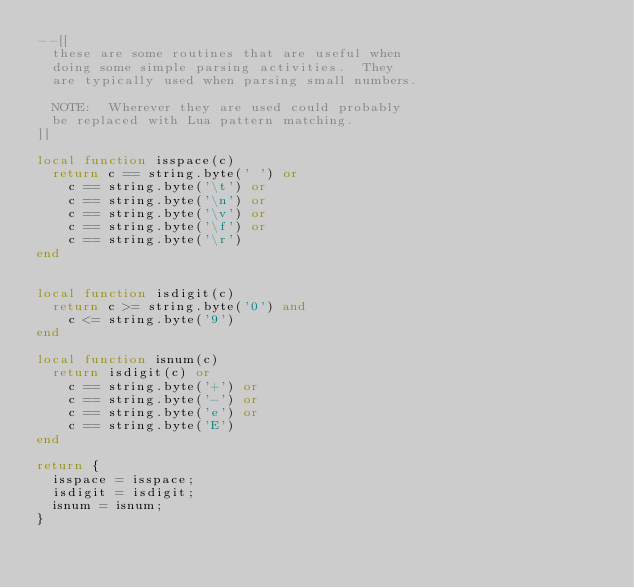<code> <loc_0><loc_0><loc_500><loc_500><_Lua_>--[[
	these are some routines that are useful when
	doing some simple parsing activities.  They 
	are typically used when parsing small numbers.

	NOTE:  Wherever they are used could probably 
	be replaced with Lua pattern matching.
]]

local function isspace(c)
	return c == string.byte(' ') or
		c == string.byte('\t') or 
		c == string.byte('\n') or
		c == string.byte('\v') or
		c == string.byte('\f') or
		c == string.byte('\r')
end


local function isdigit(c)
	return c >= string.byte('0') and
		c <= string.byte('9')
end

local function isnum(c)
	return isdigit(c) or
		c == string.byte('+') or
		c == string.byte('-') or
		c == string.byte('e') or
		c == string.byte('E')
end

return {
	isspace = isspace;
	isdigit = isdigit;
	isnum = isnum;
}</code> 